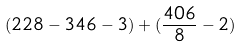Convert formula to latex. <formula><loc_0><loc_0><loc_500><loc_500>( 2 2 8 - 3 4 6 - 3 ) + ( \frac { 4 0 6 } { 8 } - 2 )</formula> 